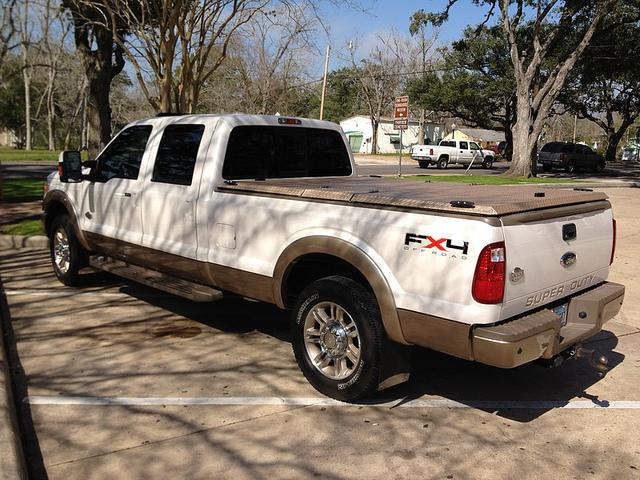What is the cover on the back of the truck called?

Choices:
A) blanket
B) tarp
C) hood
D) tonneau cover tonneau cover 